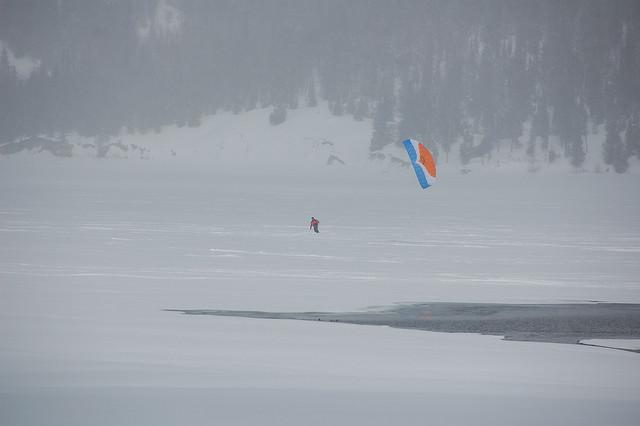Is it cold outside?
Quick response, please. Yes. Is it snowing?
Answer briefly. Yes. Is that a kite?
Keep it brief. Yes. What is different about this skier?
Quick response, please. Kite. 